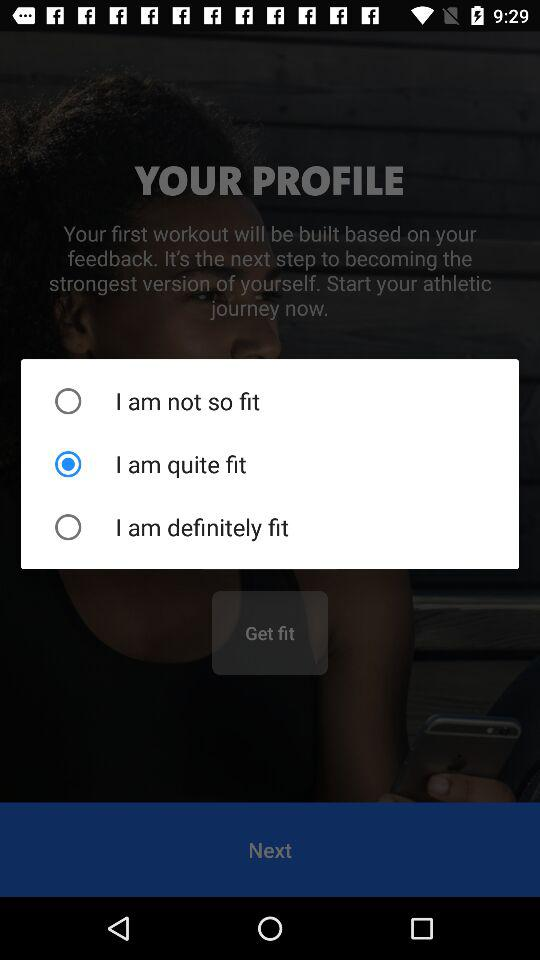Which is the selected option? The selected option is "I am quite fit". 